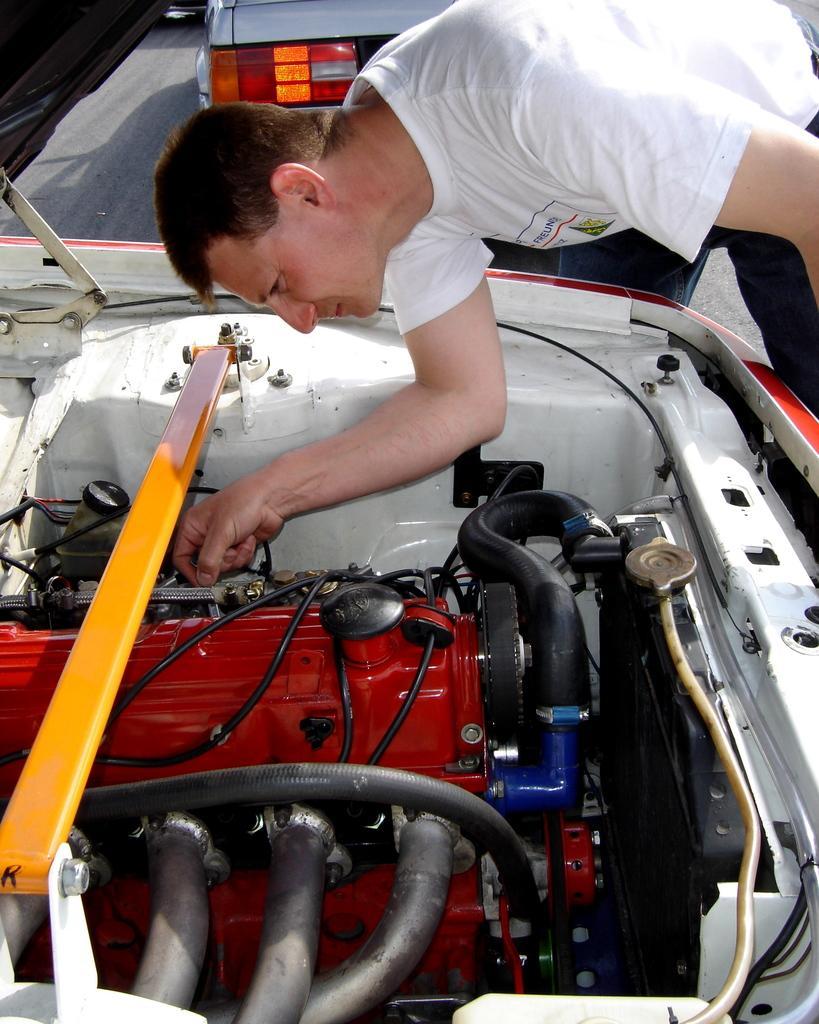In one or two sentences, can you explain what this image depicts? In the foreground of this picture, we see a man in white T shirt and in front of him there is car with opened bonnet and in the background we see a vehicle. 